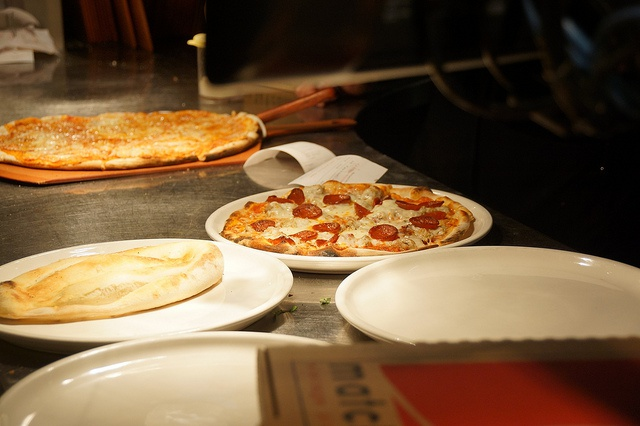Describe the objects in this image and their specific colors. I can see pizza in black, tan, red, and maroon tones, pizza in black, orange, and khaki tones, and pizza in black, khaki, orange, gold, and beige tones in this image. 